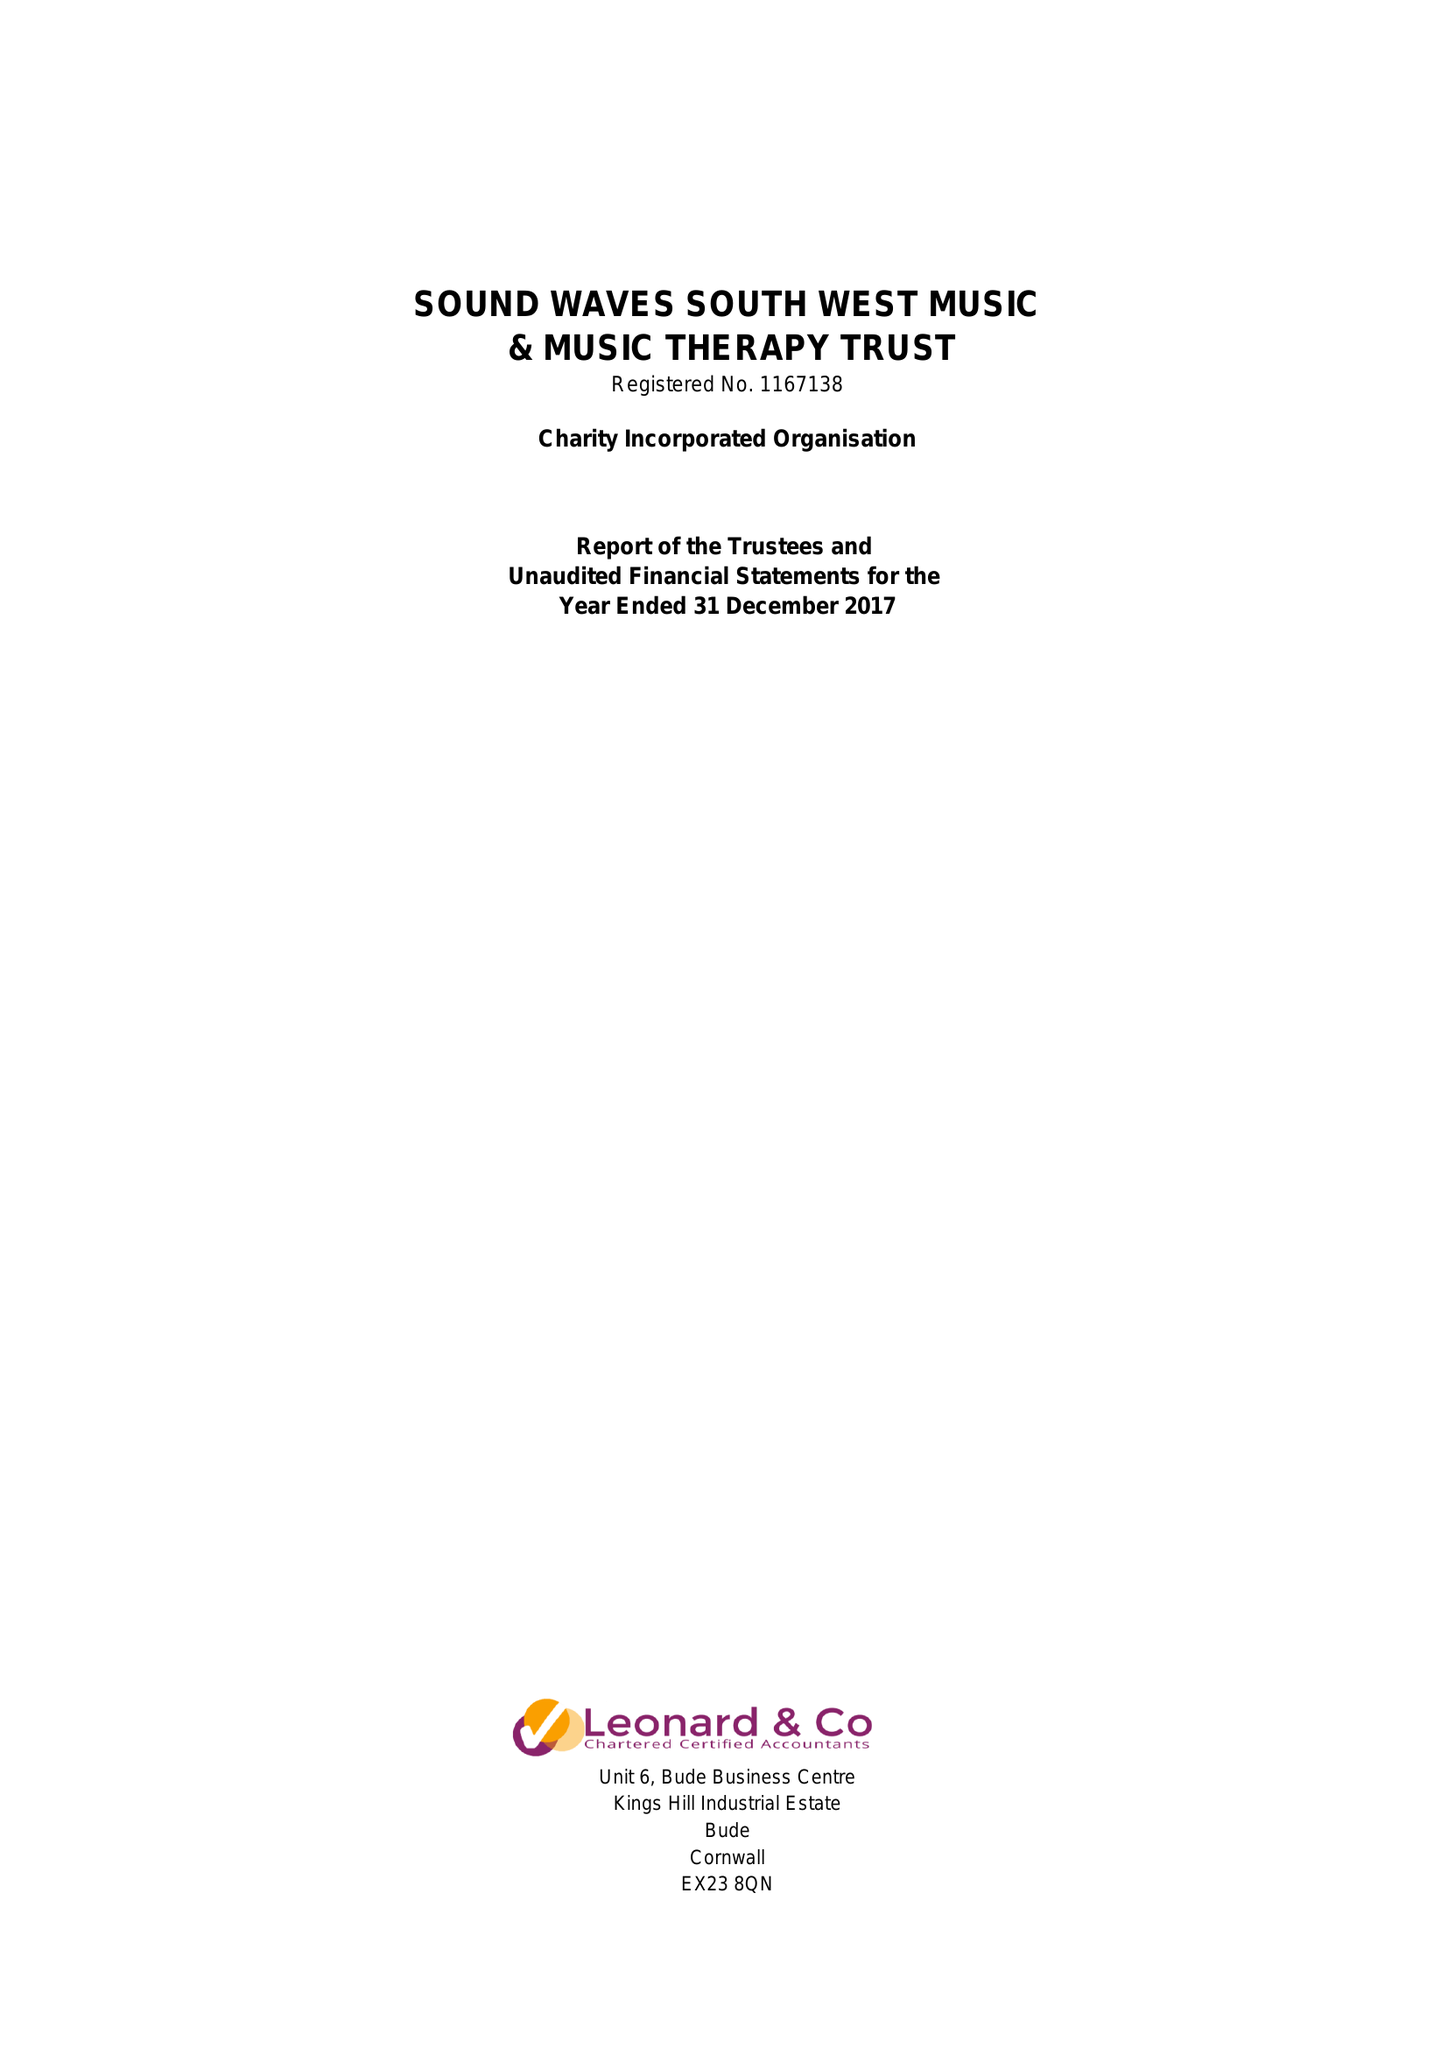What is the value for the address__street_line?
Answer the question using a single word or phrase. WOODFORD 